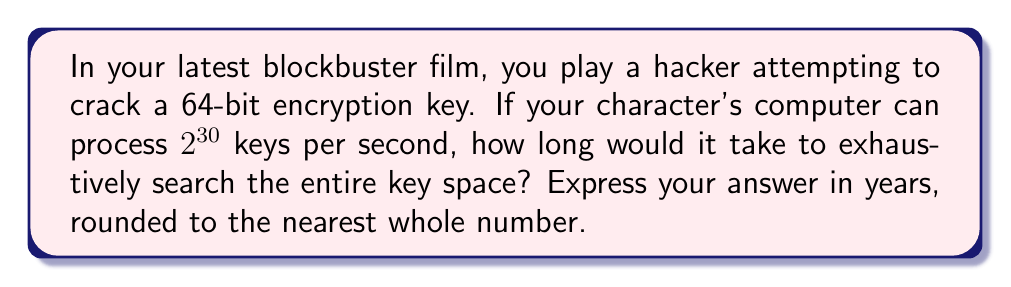Solve this math problem. To solve this problem, we'll follow these steps:

1) First, let's calculate the total number of possible keys in a 64-bit encryption:
   $$\text{Total keys} = 2^{64}$$

2) Now, let's convert the processing speed to keys per year:
   $$\text{Keys per second} = 2^{30}$$
   $$\text{Seconds in a year} = 365.25 \times 24 \times 60 \times 60 = 31,557,600$$
   $$\text{Keys per year} = 2^{30} \times 31,557,600 = 2^{30} \times 2^{24.91} \approx 2^{54.91}$$

3) To find the time required, we divide the total number of keys by the keys processed per year:
   $$\text{Time (in years)} = \frac{2^{64}}{2^{54.91}} = 2^{64-54.91} = 2^{9.09} \approx 549.76$$

4) Rounding to the nearest whole number:
   $$\text{Time} \approx 550 \text{ years}$$
Answer: 550 years 